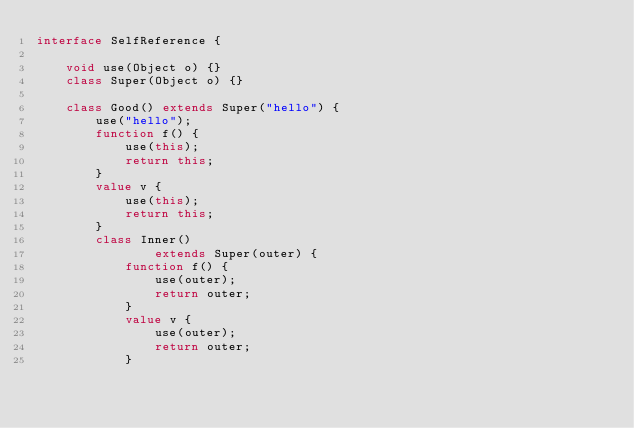Convert code to text. <code><loc_0><loc_0><loc_500><loc_500><_Ceylon_>interface SelfReference {
    
    void use(Object o) {}
    class Super(Object o) {}
    
    class Good() extends Super("hello") {
        use("hello");
        function f() {
            use(this);
            return this;
        }
        value v {
            use(this);
            return this;
        }
        class Inner() 
                extends Super(outer) {
            function f() {
                use(outer);
                return outer;
            }
            value v {
                use(outer);
                return outer;
            }</code> 